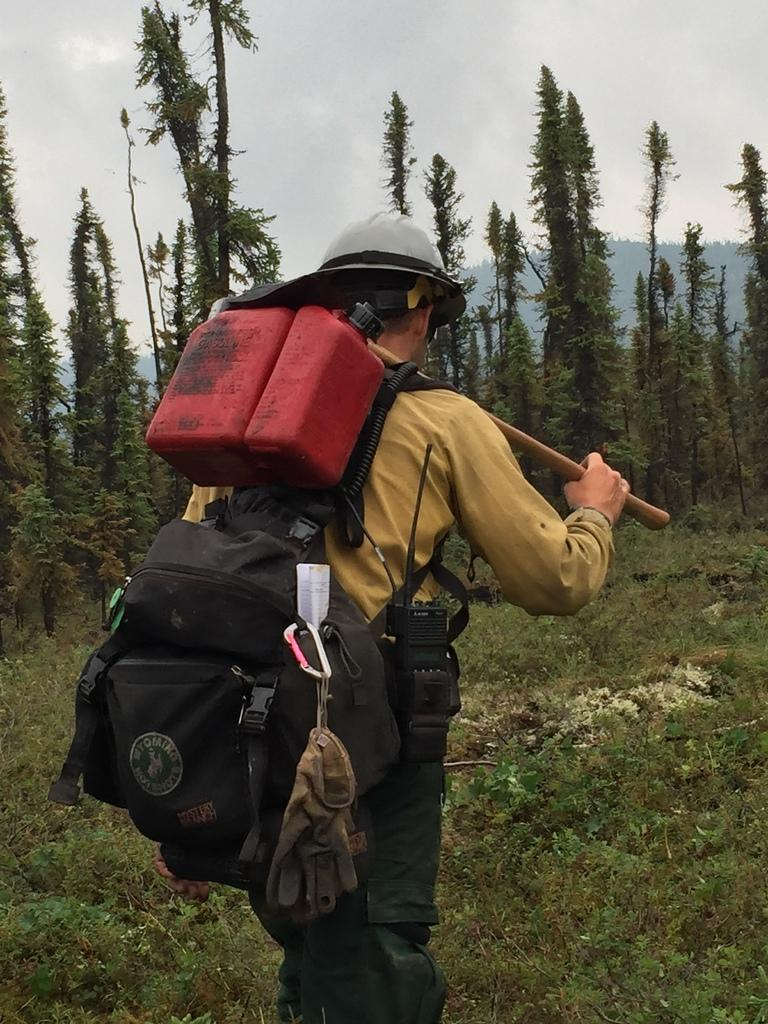What is the person in the image doing? The person is standing. What is the person wearing that is visible in the image? The person is wearing a bag. What object is the person holding in the image? The person is holding a stick. What can be seen in the distance in the image? There are trees and plants in the distance. How would you describe the sky in the image? The sky is cloudy. What type of animals can be seen in the zoo in the image? There is no zoo present in the image, so it is not possible to determine what animals might be seen. 